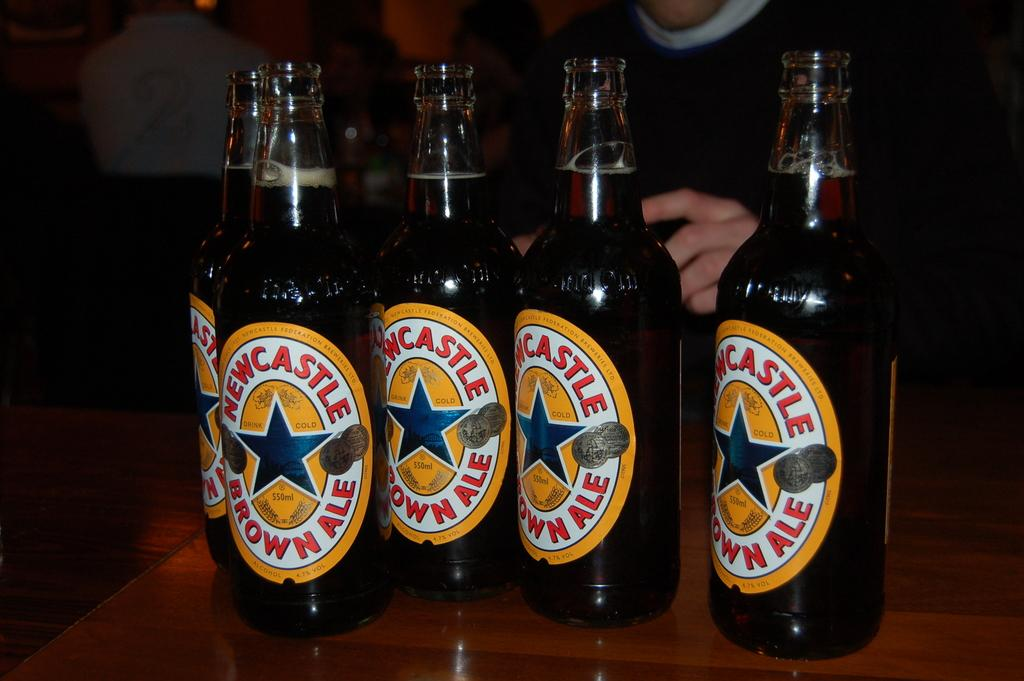<image>
Summarize the visual content of the image. several bottles of New castle brown ale sit on a table 